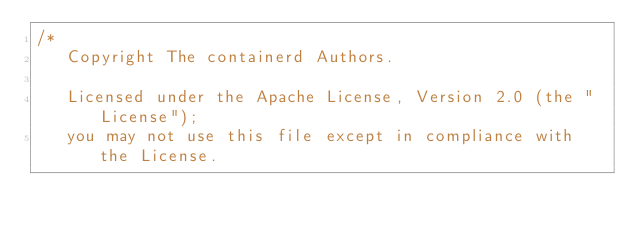Convert code to text. <code><loc_0><loc_0><loc_500><loc_500><_Go_>/*
   Copyright The containerd Authors.

   Licensed under the Apache License, Version 2.0 (the "License");
   you may not use this file except in compliance with the License.</code> 